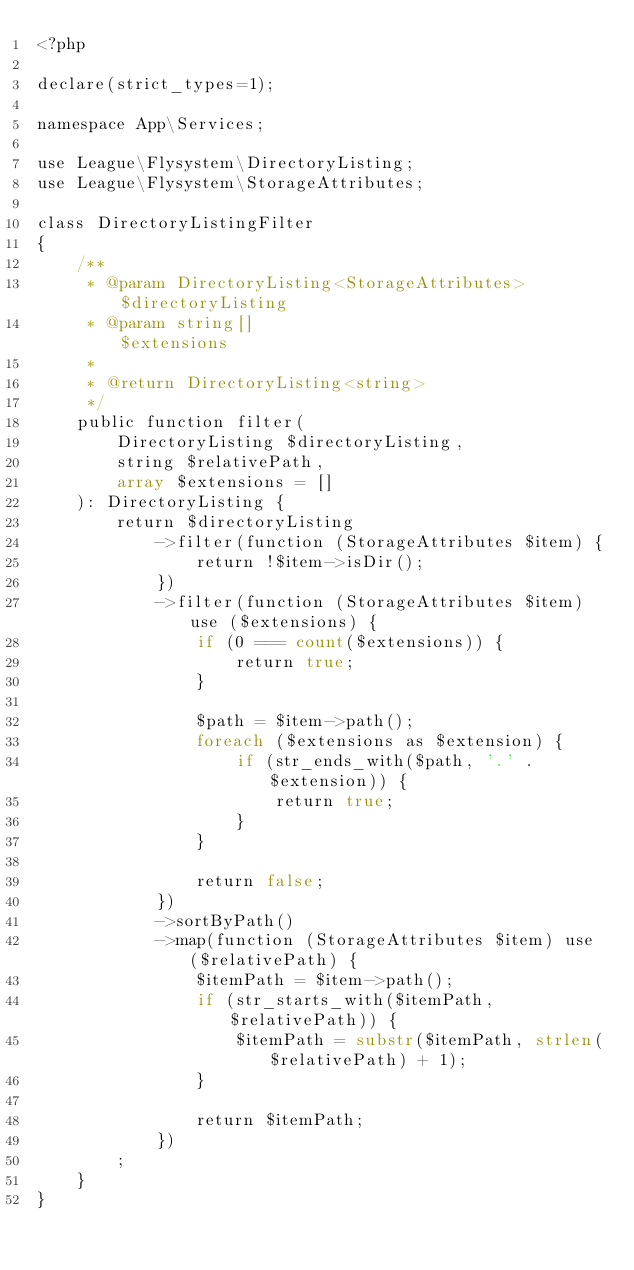Convert code to text. <code><loc_0><loc_0><loc_500><loc_500><_PHP_><?php

declare(strict_types=1);

namespace App\Services;

use League\Flysystem\DirectoryListing;
use League\Flysystem\StorageAttributes;

class DirectoryListingFilter
{
    /**
     * @param DirectoryListing<StorageAttributes> $directoryListing
     * @param string[]                            $extensions
     *
     * @return DirectoryListing<string>
     */
    public function filter(
        DirectoryListing $directoryListing,
        string $relativePath,
        array $extensions = []
    ): DirectoryListing {
        return $directoryListing
            ->filter(function (StorageAttributes $item) {
                return !$item->isDir();
            })
            ->filter(function (StorageAttributes $item) use ($extensions) {
                if (0 === count($extensions)) {
                    return true;
                }

                $path = $item->path();
                foreach ($extensions as $extension) {
                    if (str_ends_with($path, '.' . $extension)) {
                        return true;
                    }
                }

                return false;
            })
            ->sortByPath()
            ->map(function (StorageAttributes $item) use ($relativePath) {
                $itemPath = $item->path();
                if (str_starts_with($itemPath, $relativePath)) {
                    $itemPath = substr($itemPath, strlen($relativePath) + 1);
                }

                return $itemPath;
            })
        ;
    }
}
</code> 